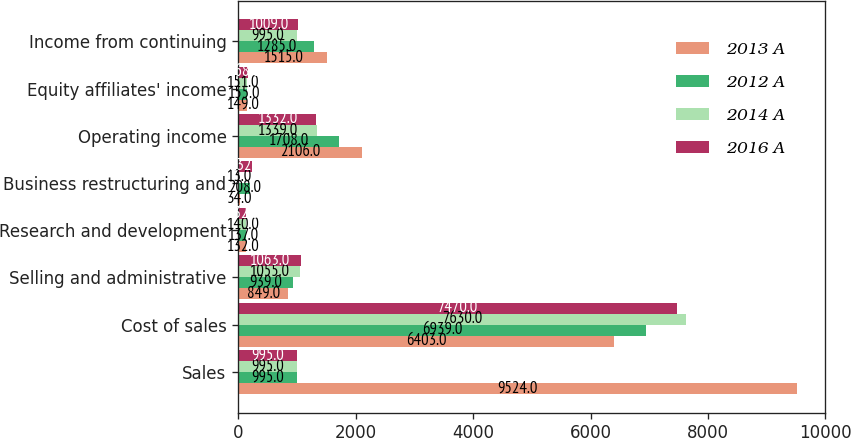<chart> <loc_0><loc_0><loc_500><loc_500><stacked_bar_chart><ecel><fcel>Sales<fcel>Cost of sales<fcel>Selling and administrative<fcel>Research and development<fcel>Business restructuring and<fcel>Operating income<fcel>Equity affiliates' income<fcel>Income from continuing<nl><fcel>2013 A<fcel>9524<fcel>6403<fcel>849<fcel>132<fcel>34<fcel>2106<fcel>149<fcel>1515<nl><fcel>2012 A<fcel>995<fcel>6939<fcel>939<fcel>137<fcel>208<fcel>1708<fcel>155<fcel>1285<nl><fcel>2014 A<fcel>995<fcel>7630<fcel>1055<fcel>140<fcel>13<fcel>1339<fcel>151<fcel>995<nl><fcel>2016 A<fcel>995<fcel>7470<fcel>1063<fcel>132<fcel>232<fcel>1332<fcel>168<fcel>1009<nl></chart> 